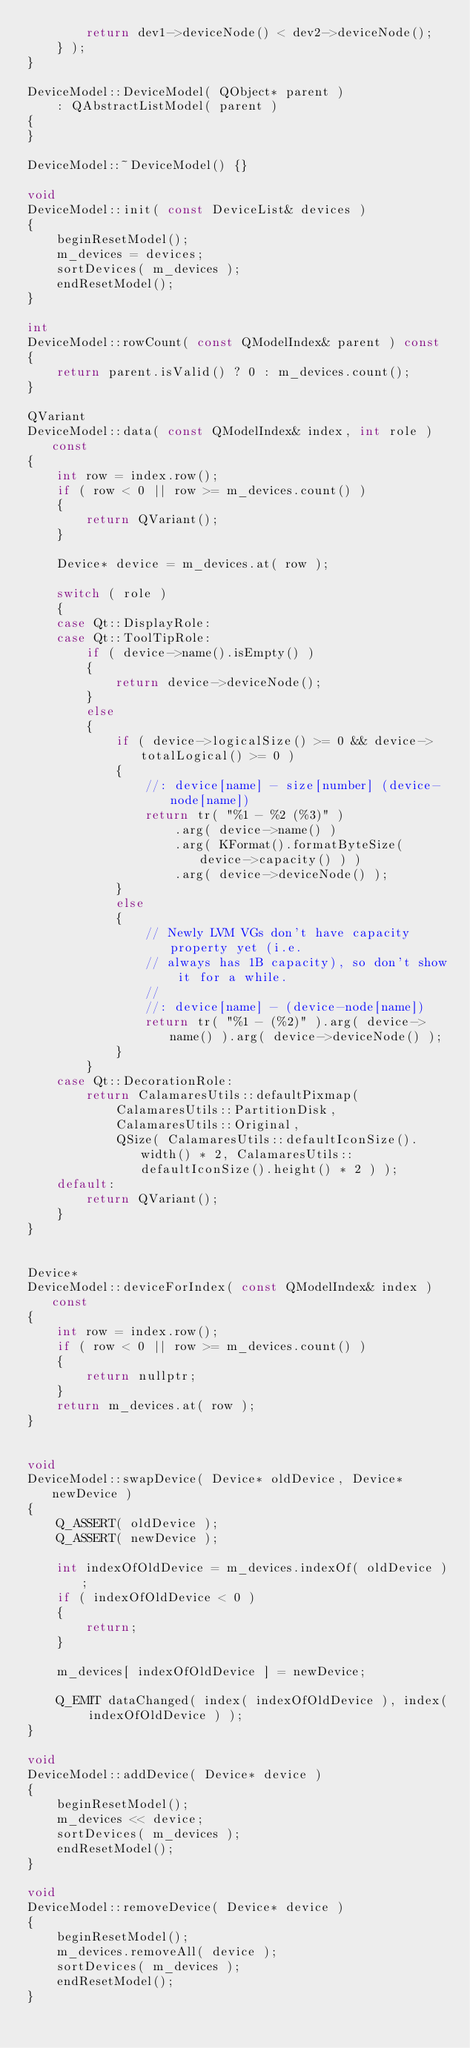<code> <loc_0><loc_0><loc_500><loc_500><_C++_>        return dev1->deviceNode() < dev2->deviceNode();
    } );
}

DeviceModel::DeviceModel( QObject* parent )
    : QAbstractListModel( parent )
{
}

DeviceModel::~DeviceModel() {}

void
DeviceModel::init( const DeviceList& devices )
{
    beginResetModel();
    m_devices = devices;
    sortDevices( m_devices );
    endResetModel();
}

int
DeviceModel::rowCount( const QModelIndex& parent ) const
{
    return parent.isValid() ? 0 : m_devices.count();
}

QVariant
DeviceModel::data( const QModelIndex& index, int role ) const
{
    int row = index.row();
    if ( row < 0 || row >= m_devices.count() )
    {
        return QVariant();
    }

    Device* device = m_devices.at( row );

    switch ( role )
    {
    case Qt::DisplayRole:
    case Qt::ToolTipRole:
        if ( device->name().isEmpty() )
        {
            return device->deviceNode();
        }
        else
        {
            if ( device->logicalSize() >= 0 && device->totalLogical() >= 0 )
            {
                //: device[name] - size[number] (device-node[name])
                return tr( "%1 - %2 (%3)" )
                    .arg( device->name() )
                    .arg( KFormat().formatByteSize( device->capacity() ) )
                    .arg( device->deviceNode() );
            }
            else
            {
                // Newly LVM VGs don't have capacity property yet (i.e.
                // always has 1B capacity), so don't show it for a while.
                //
                //: device[name] - (device-node[name])
                return tr( "%1 - (%2)" ).arg( device->name() ).arg( device->deviceNode() );
            }
        }
    case Qt::DecorationRole:
        return CalamaresUtils::defaultPixmap(
            CalamaresUtils::PartitionDisk,
            CalamaresUtils::Original,
            QSize( CalamaresUtils::defaultIconSize().width() * 2, CalamaresUtils::defaultIconSize().height() * 2 ) );
    default:
        return QVariant();
    }
}


Device*
DeviceModel::deviceForIndex( const QModelIndex& index ) const
{
    int row = index.row();
    if ( row < 0 || row >= m_devices.count() )
    {
        return nullptr;
    }
    return m_devices.at( row );
}


void
DeviceModel::swapDevice( Device* oldDevice, Device* newDevice )
{
    Q_ASSERT( oldDevice );
    Q_ASSERT( newDevice );

    int indexOfOldDevice = m_devices.indexOf( oldDevice );
    if ( indexOfOldDevice < 0 )
    {
        return;
    }

    m_devices[ indexOfOldDevice ] = newDevice;

    Q_EMIT dataChanged( index( indexOfOldDevice ), index( indexOfOldDevice ) );
}

void
DeviceModel::addDevice( Device* device )
{
    beginResetModel();
    m_devices << device;
    sortDevices( m_devices );
    endResetModel();
}

void
DeviceModel::removeDevice( Device* device )
{
    beginResetModel();
    m_devices.removeAll( device );
    sortDevices( m_devices );
    endResetModel();
}
</code> 